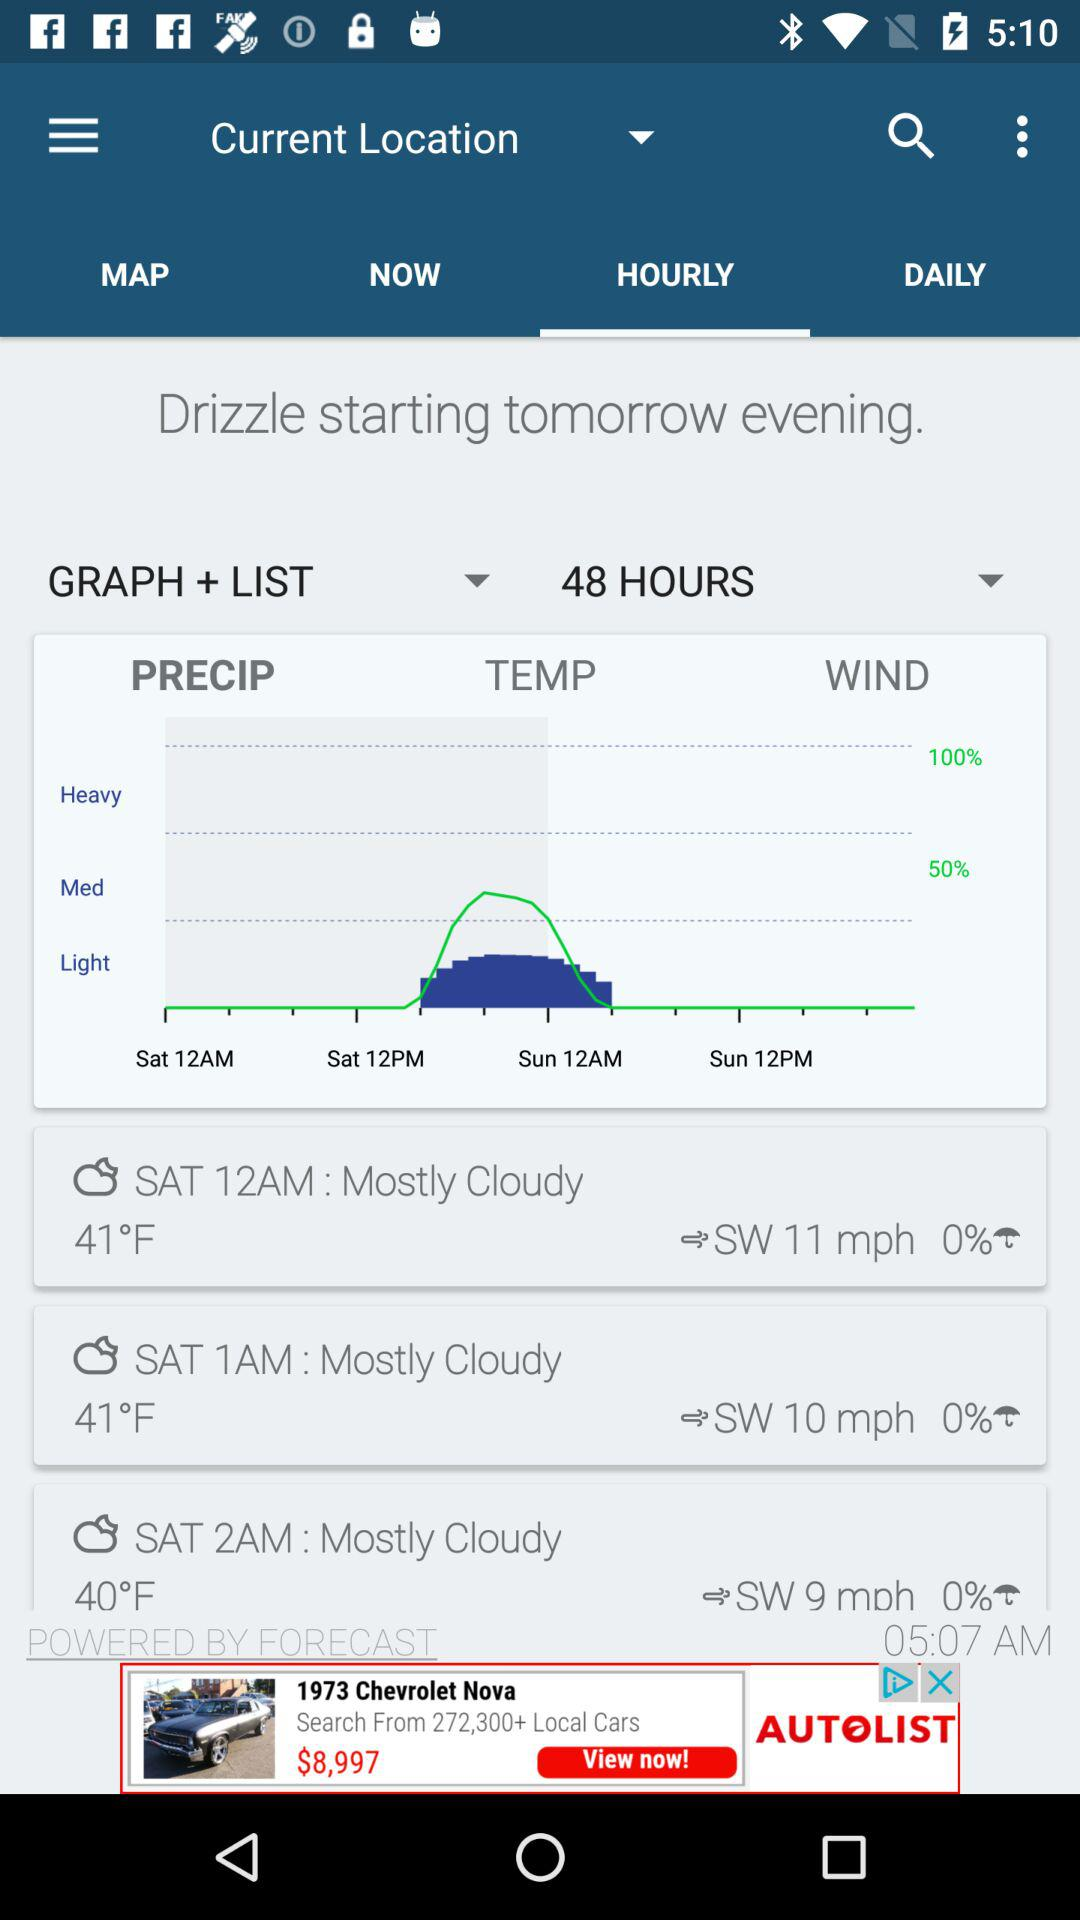Can you summarize the weather conditions expected for this location during the next 48 hours according to the image? Based on the image, it appears that the weather for this location over the next 48 hours is expected to be mostly cloudy with temperatures fluctuating between 40°F and 50°F. There's a chance of light to medium precipitation peaking around midday, and winds ranging from 9 to 11 mph. 